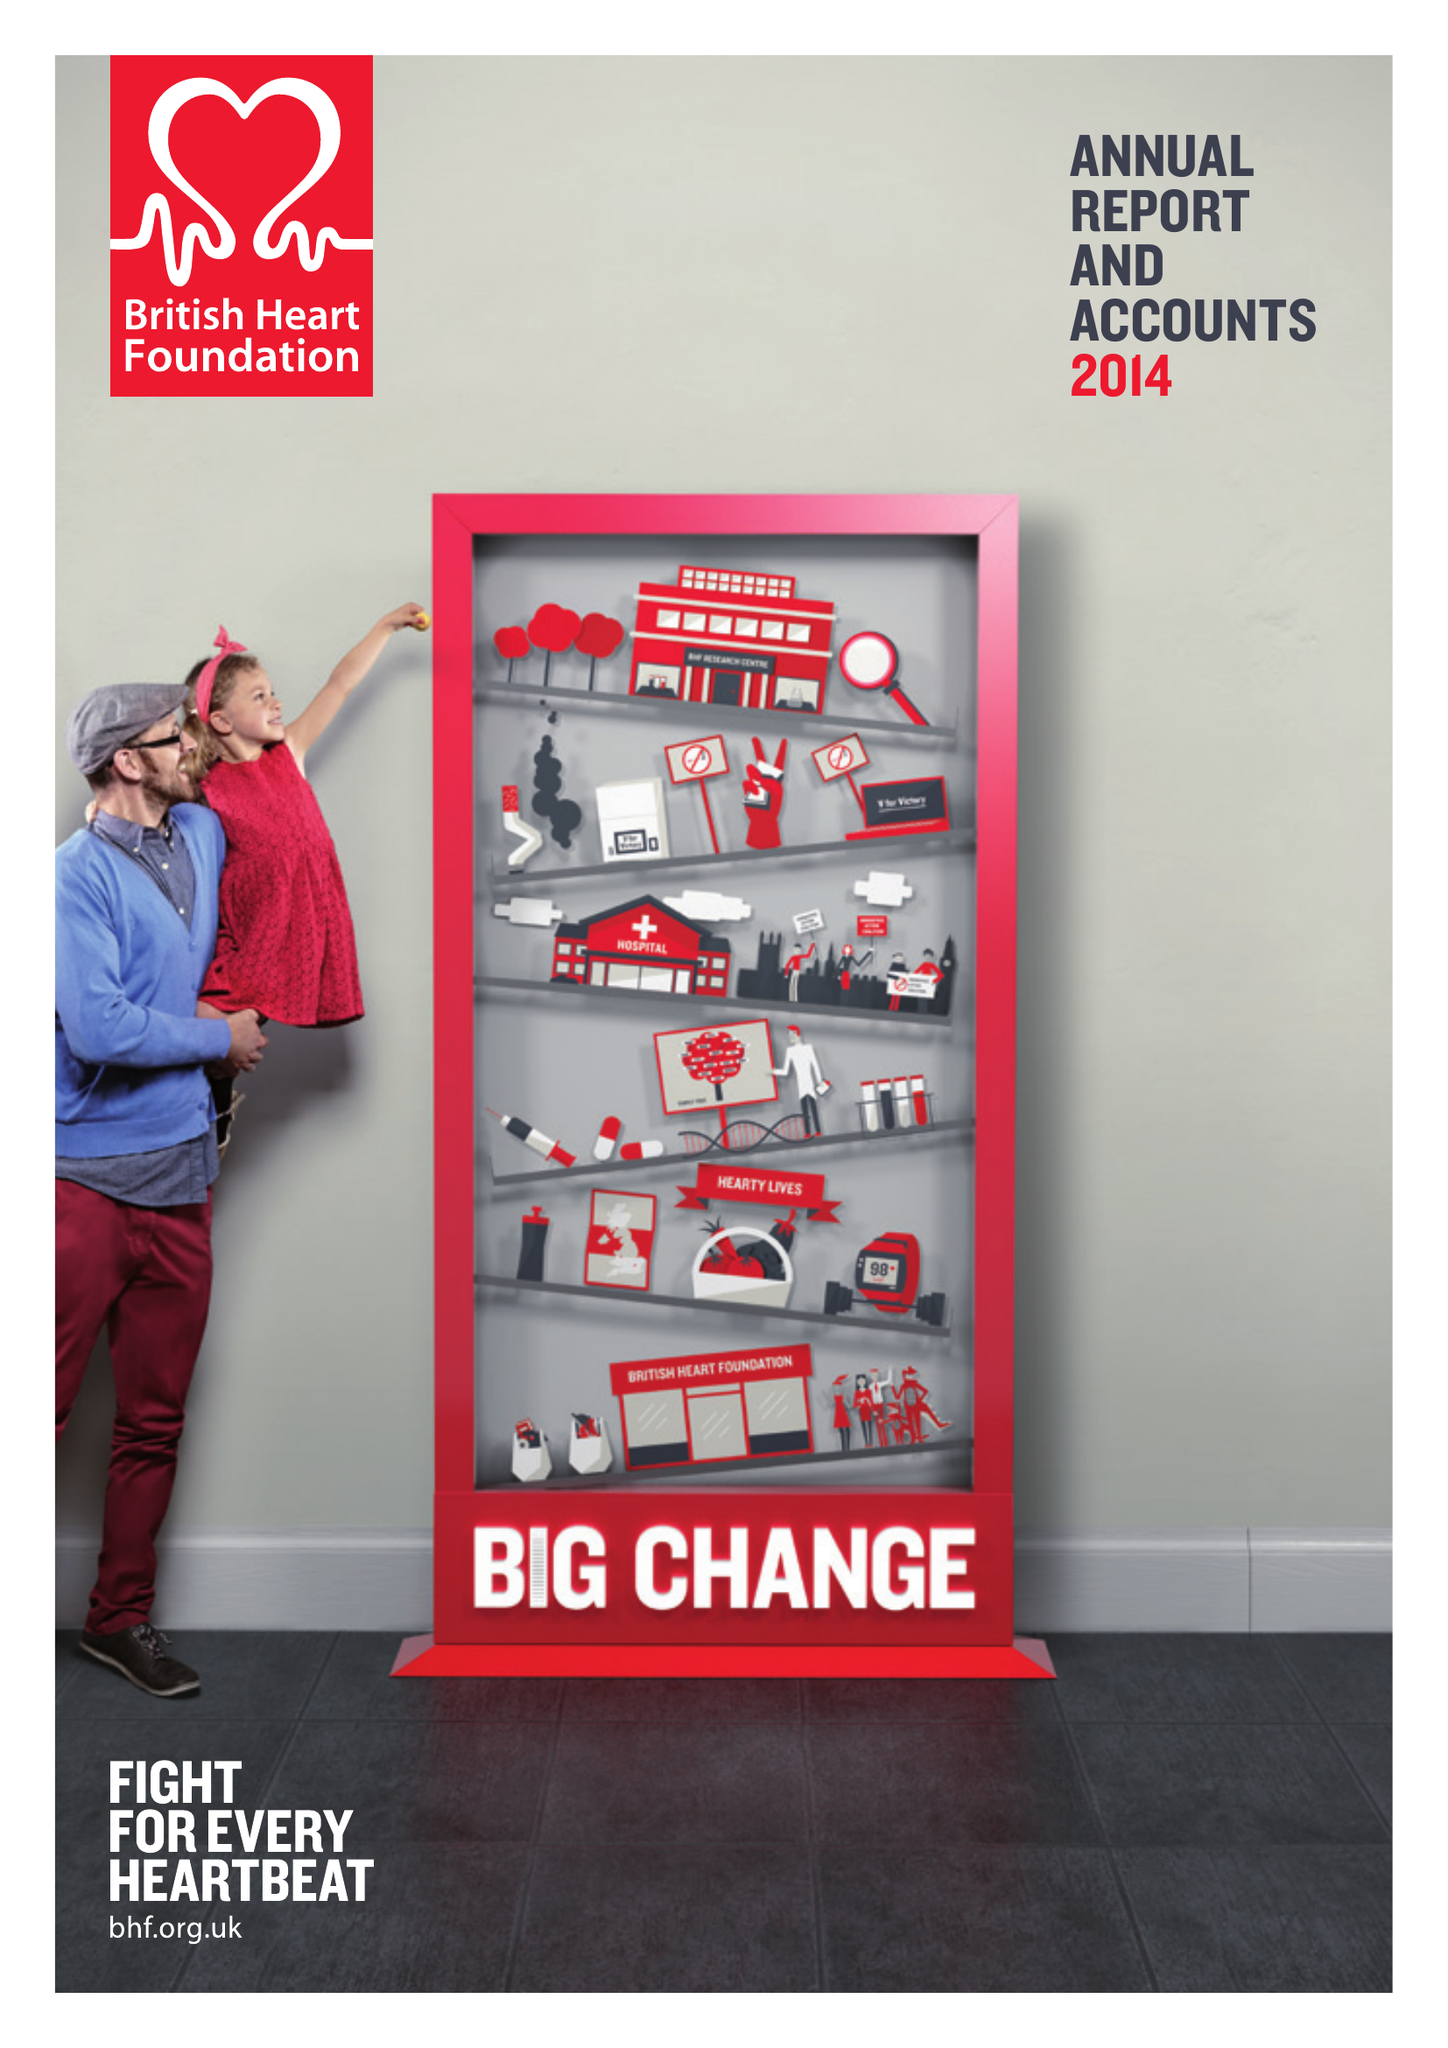What is the value for the charity_name?
Answer the question using a single word or phrase. British Heart Foundation 